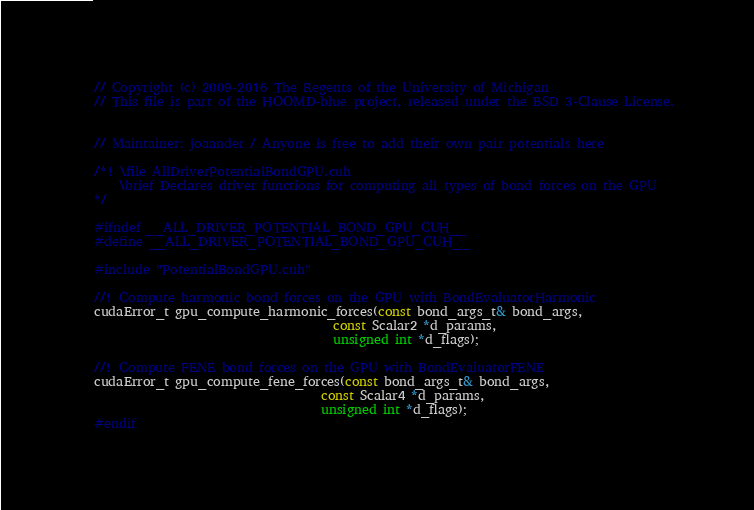<code> <loc_0><loc_0><loc_500><loc_500><_Cuda_>// Copyright (c) 2009-2016 The Regents of the University of Michigan
// This file is part of the HOOMD-blue project, released under the BSD 3-Clause License.


// Maintainer: joaander / Anyone is free to add their own pair potentials here

/*! \file AllDriverPotentialBondGPU.cuh
    \brief Declares driver functions for computing all types of bond forces on the GPU
*/

#ifndef __ALL_DRIVER_POTENTIAL_BOND_GPU_CUH__
#define __ALL_DRIVER_POTENTIAL_BOND_GPU_CUH__

#include "PotentialBondGPU.cuh"

//! Compute harmonic bond forces on the GPU with BondEvaluatorHarmonic
cudaError_t gpu_compute_harmonic_forces(const bond_args_t& bond_args,
                                      const Scalar2 *d_params,
                                      unsigned int *d_flags);

//! Compute FENE bond forces on the GPU with BondEvaluatorFENE
cudaError_t gpu_compute_fene_forces(const bond_args_t& bond_args,
                                    const Scalar4 *d_params,
                                    unsigned int *d_flags);
#endif
</code> 